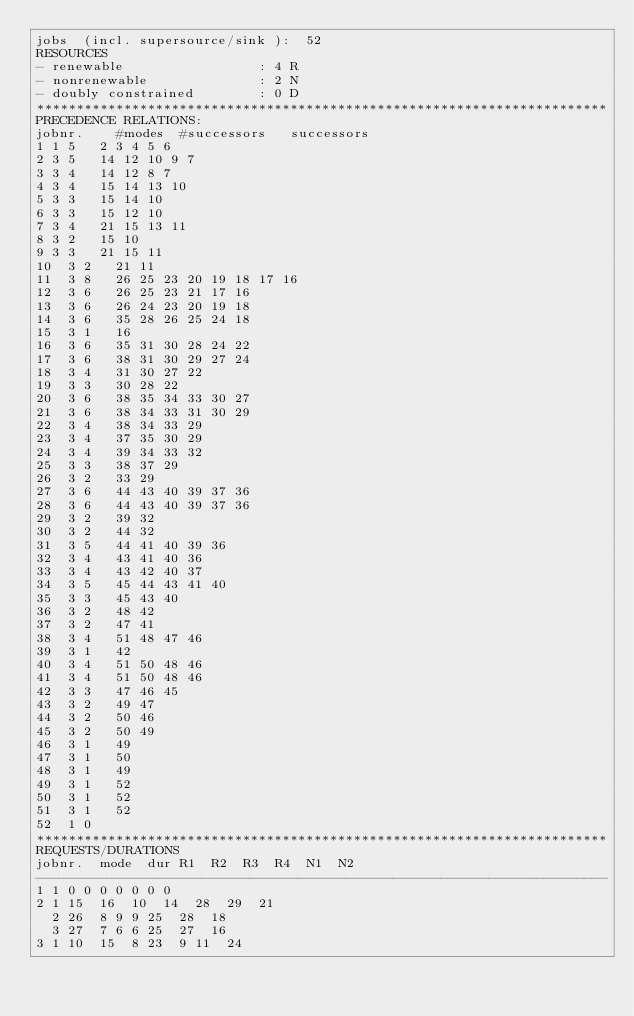<code> <loc_0><loc_0><loc_500><loc_500><_ObjectiveC_>jobs  (incl. supersource/sink ):	52
RESOURCES
- renewable                 : 4 R
- nonrenewable              : 2 N
- doubly constrained        : 0 D
************************************************************************
PRECEDENCE RELATIONS:
jobnr.    #modes  #successors   successors
1	1	5		2 3 4 5 6 
2	3	5		14 12 10 9 7 
3	3	4		14 12 8 7 
4	3	4		15 14 13 10 
5	3	3		15 14 10 
6	3	3		15 12 10 
7	3	4		21 15 13 11 
8	3	2		15 10 
9	3	3		21 15 11 
10	3	2		21 11 
11	3	8		26 25 23 20 19 18 17 16 
12	3	6		26 25 23 21 17 16 
13	3	6		26 24 23 20 19 18 
14	3	6		35 28 26 25 24 18 
15	3	1		16 
16	3	6		35 31 30 28 24 22 
17	3	6		38 31 30 29 27 24 
18	3	4		31 30 27 22 
19	3	3		30 28 22 
20	3	6		38 35 34 33 30 27 
21	3	6		38 34 33 31 30 29 
22	3	4		38 34 33 29 
23	3	4		37 35 30 29 
24	3	4		39 34 33 32 
25	3	3		38 37 29 
26	3	2		33 29 
27	3	6		44 43 40 39 37 36 
28	3	6		44 43 40 39 37 36 
29	3	2		39 32 
30	3	2		44 32 
31	3	5		44 41 40 39 36 
32	3	4		43 41 40 36 
33	3	4		43 42 40 37 
34	3	5		45 44 43 41 40 
35	3	3		45 43 40 
36	3	2		48 42 
37	3	2		47 41 
38	3	4		51 48 47 46 
39	3	1		42 
40	3	4		51 50 48 46 
41	3	4		51 50 48 46 
42	3	3		47 46 45 
43	3	2		49 47 
44	3	2		50 46 
45	3	2		50 49 
46	3	1		49 
47	3	1		50 
48	3	1		49 
49	3	1		52 
50	3	1		52 
51	3	1		52 
52	1	0		
************************************************************************
REQUESTS/DURATIONS
jobnr.	mode	dur	R1	R2	R3	R4	N1	N2	
------------------------------------------------------------------------
1	1	0	0	0	0	0	0	0	
2	1	15	16	10	14	28	29	21	
	2	26	8	9	9	25	28	18	
	3	27	7	6	6	25	27	16	
3	1	10	15	8	23	9	11	24	</code> 